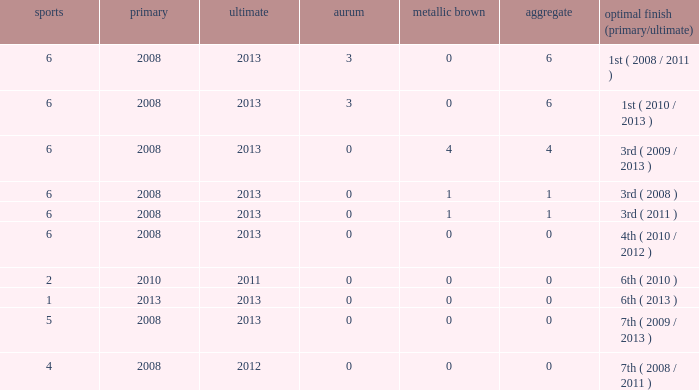How many games have more than 0 golds and began before 2008? None. 